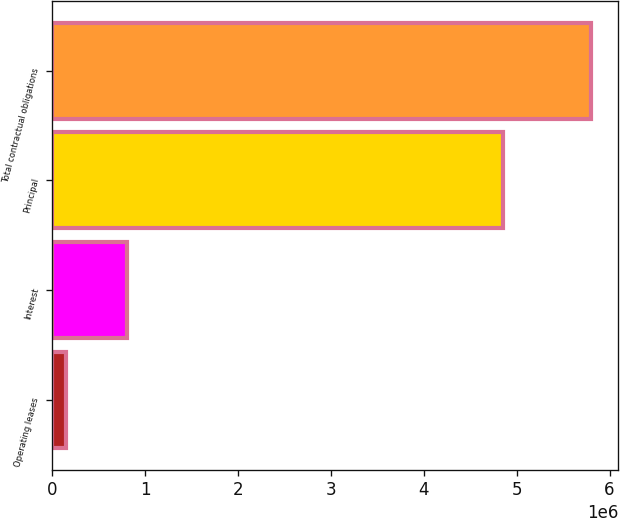<chart> <loc_0><loc_0><loc_500><loc_500><bar_chart><fcel>Operating leases<fcel>Interest<fcel>Principal<fcel>Total contractual obligations<nl><fcel>151158<fcel>800214<fcel>4.85408e+06<fcel>5.80545e+06<nl></chart> 